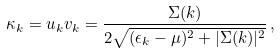Convert formula to latex. <formula><loc_0><loc_0><loc_500><loc_500>\kappa _ { k } = u _ { k } v _ { k } = \frac { \Sigma ( k ) } { 2 \sqrt { ( \epsilon _ { k } - \mu ) ^ { 2 } + | \Sigma ( k ) | ^ { 2 } } } \, ,</formula> 